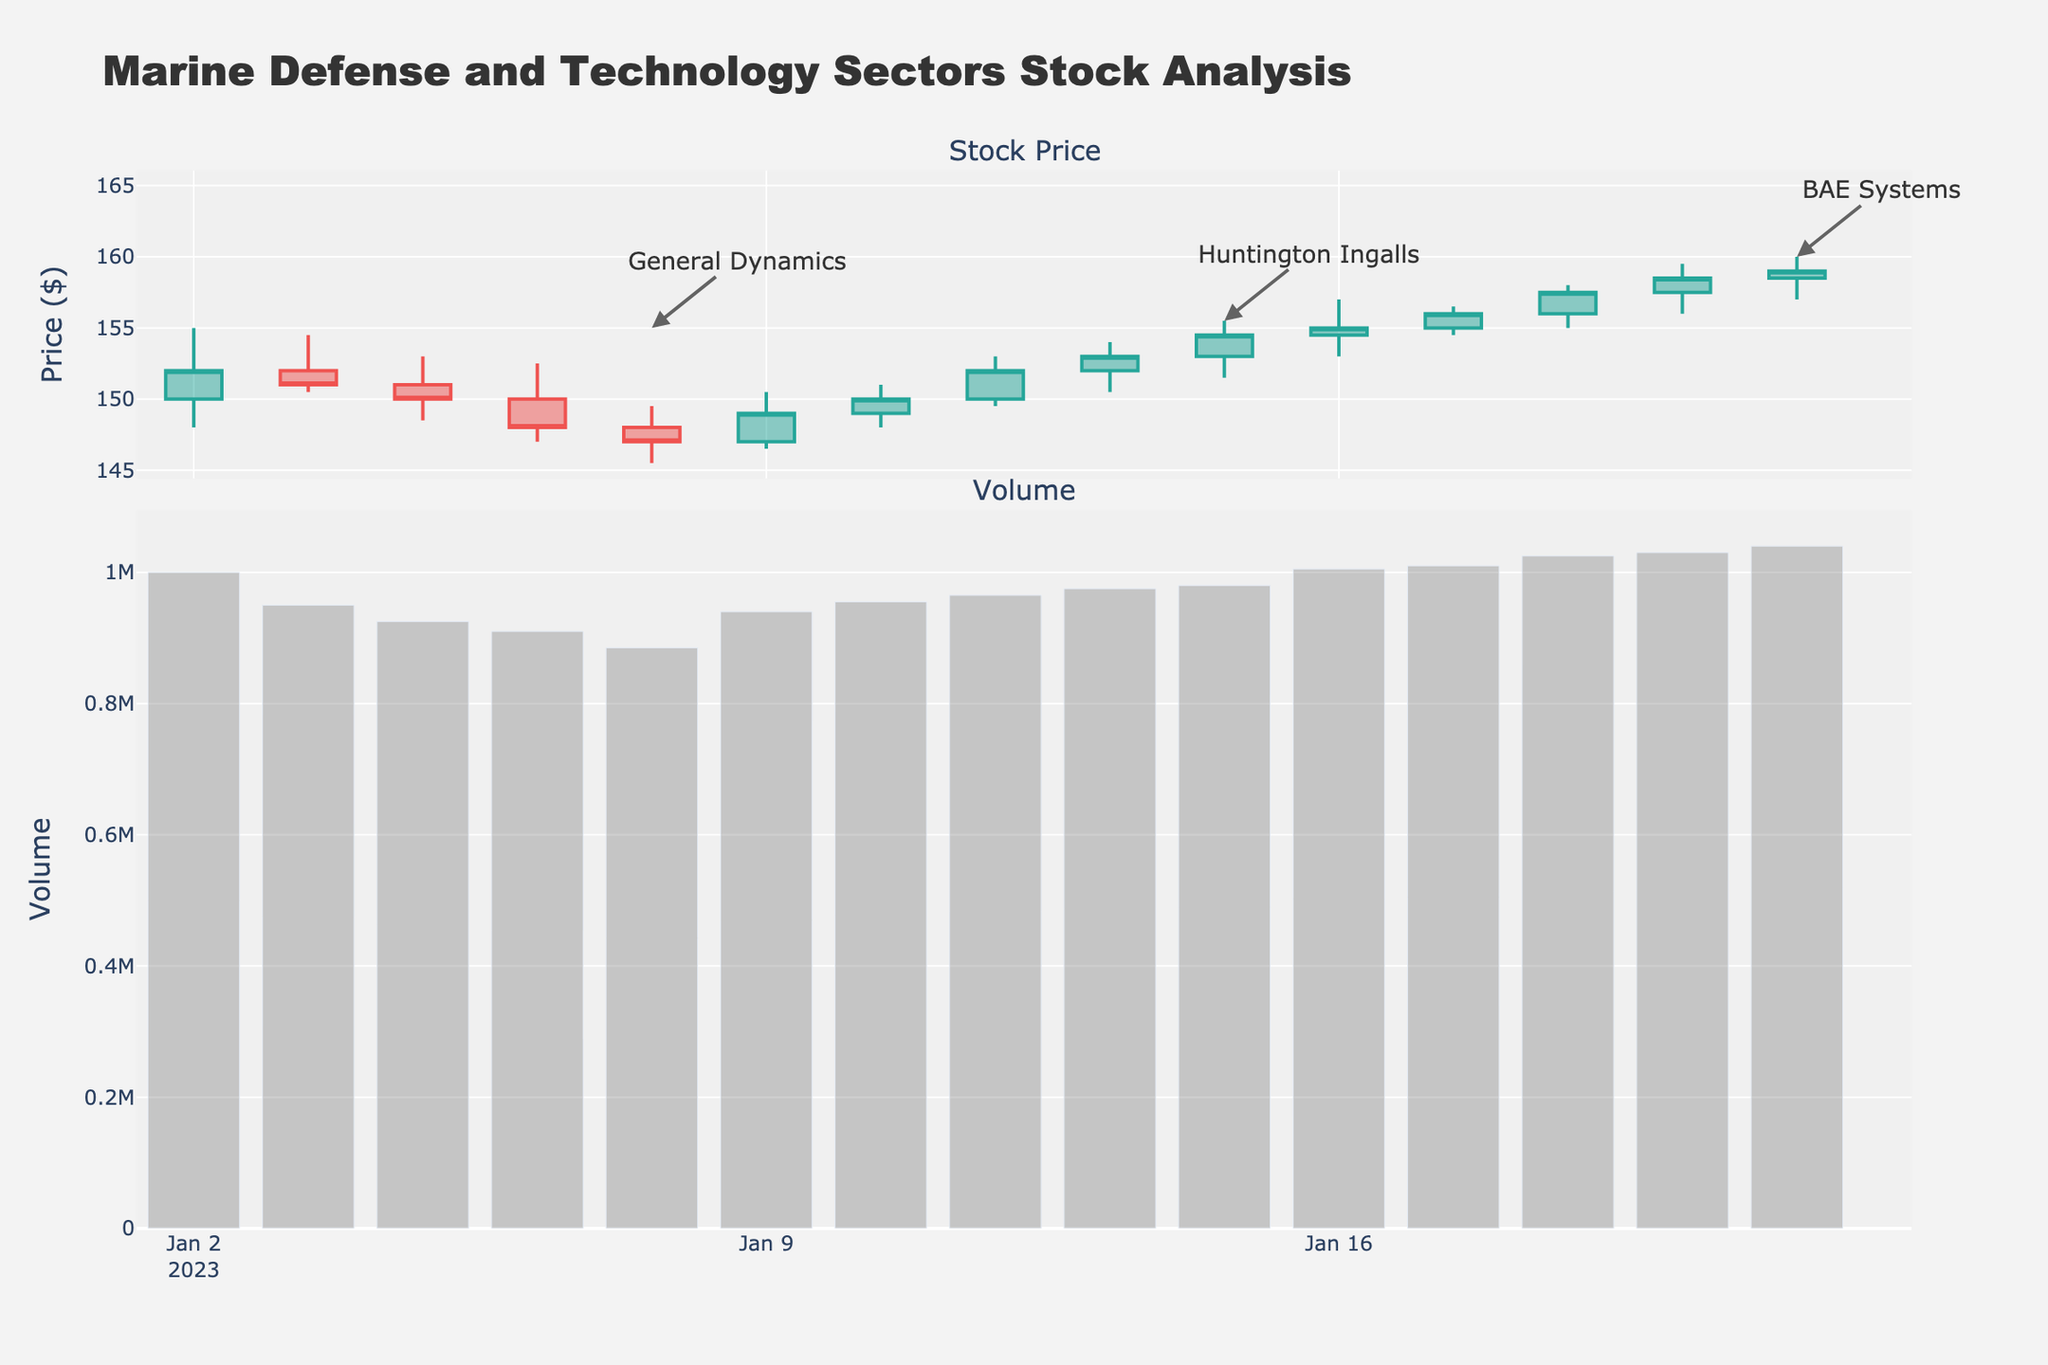What is the overall trend of the stock prices in the figure? The overall trend is identified by following the sequence of the closing prices along the time axis. From January 2 to January 20, the general trend shows a gradual increase in stock prices.
Answer: Increasing How many companies are represented in the figure? To determine the number of companies, count the unique annotations on the figure. There are labels for General Dynamics, Huntington Ingalls, and BAE Systems.
Answer: 3 Which company had the highest closing price during the period shown? To find this, identify the maximum closing price value annotated in the figure. The highest closing price is for BAE Systems on January 20 with $159.00.
Answer: BAE Systems What is the average closing price for General Dynamics? Find the closing prices for General Dynamics, which are $152.00, $151.00, $150.00, $148.00, and $147.00, then calculate the average: (152 + 151 + 150 + 148 + 147) / 5 = 149.6
Answer: $149.6 How does the trading volume on January 12 for Huntington Ingalls compare to January 9? Look at the bar chart section for volumes corresponding to these dates. January 12 has a higher bar, indicating a higher volume compared to January 9.
Answer: Higher What was the lowest price recorded for BAE Systems during the period shown? The lowest price is the minimum value in the "Low" entries for BAE Systems. These are $153.00, $154.50, $155.00, $156.00, and $157.00; the lowest is $153.00 on January 16.
Answer: $153.00 What does the candlestick color indicate on January 4 for General Dynamics? The candlestick color can indicate whether the closing price was higher or lower than the opening. A red candlestick on January 4 indicates the closing price ($150.00) was lower than the opening price ($151.00).
Answer: Decrease Between which dates did Huntington Ingalls show the most growth in closing prices? Observe the closing prices for Huntington Ingalls: $149.00 (Jan 9), $150.00 (Jan 10), $152.00 (Jan 11), $153.00 (Jan 12), and $154.50 (Jan 13). The most significant growth seems to occur between Jan 11 to Jan 12.
Answer: January 11 to January 12 